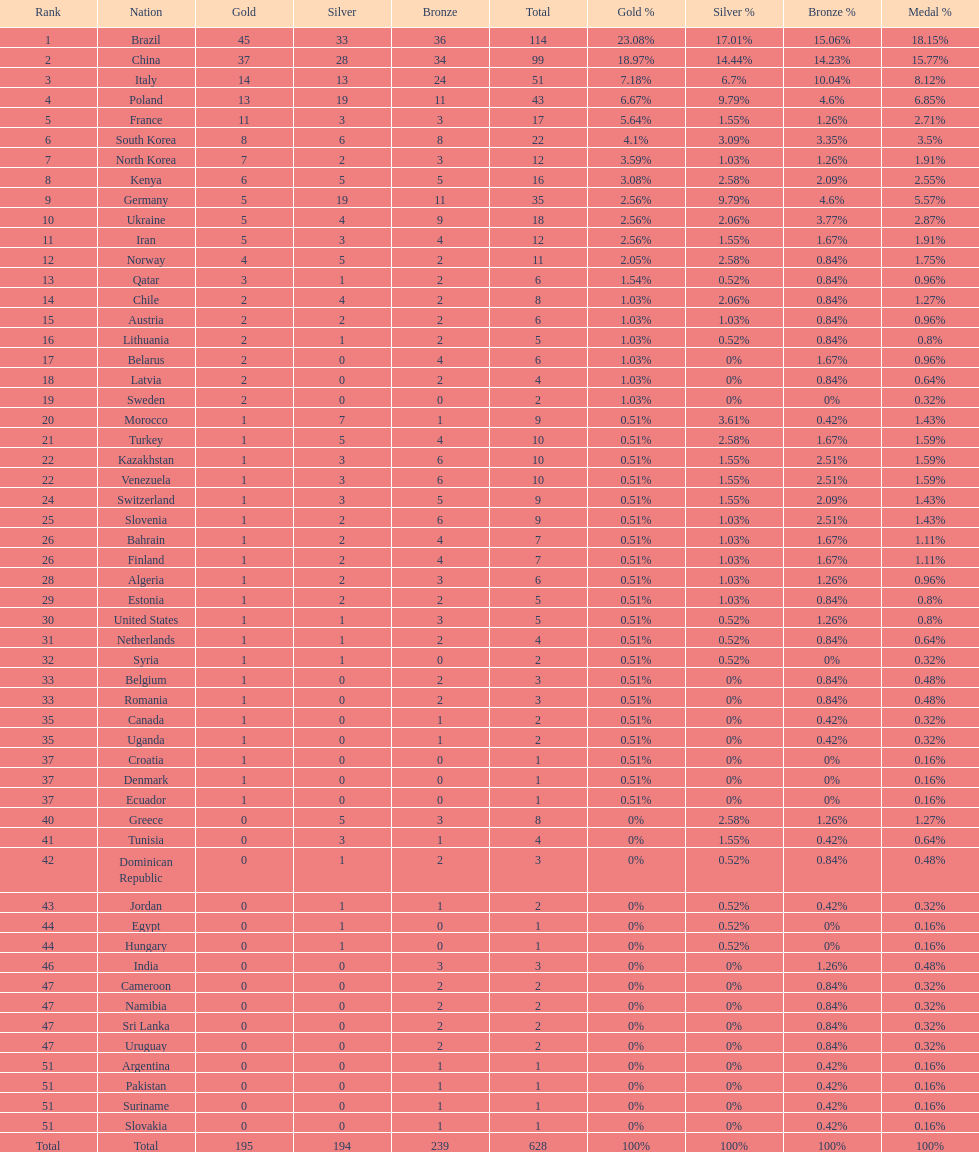How many total medals did norway win? 11. 